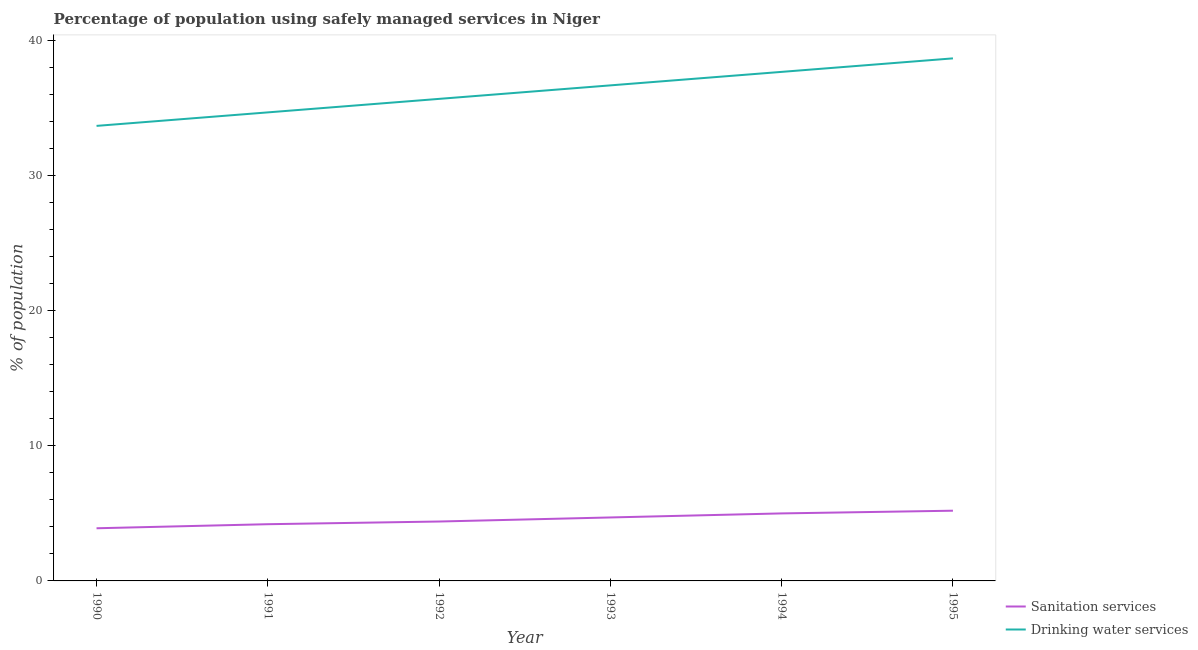How many different coloured lines are there?
Offer a terse response. 2. Across all years, what is the maximum percentage of population who used sanitation services?
Offer a very short reply. 5.2. Across all years, what is the minimum percentage of population who used drinking water services?
Your answer should be compact. 33.7. In which year was the percentage of population who used drinking water services maximum?
Provide a short and direct response. 1995. In which year was the percentage of population who used sanitation services minimum?
Keep it short and to the point. 1990. What is the total percentage of population who used drinking water services in the graph?
Your response must be concise. 217.2. What is the difference between the percentage of population who used sanitation services in 1994 and the percentage of population who used drinking water services in 1992?
Your response must be concise. -30.7. What is the average percentage of population who used sanitation services per year?
Give a very brief answer. 4.57. In the year 1993, what is the difference between the percentage of population who used sanitation services and percentage of population who used drinking water services?
Offer a terse response. -32. What is the ratio of the percentage of population who used sanitation services in 1990 to that in 1994?
Ensure brevity in your answer.  0.78. Is the difference between the percentage of population who used drinking water services in 1992 and 1995 greater than the difference between the percentage of population who used sanitation services in 1992 and 1995?
Give a very brief answer. No. What is the difference between the highest and the second highest percentage of population who used drinking water services?
Offer a terse response. 1. What is the difference between the highest and the lowest percentage of population who used sanitation services?
Provide a short and direct response. 1.3. Is the sum of the percentage of population who used drinking water services in 1990 and 1992 greater than the maximum percentage of population who used sanitation services across all years?
Your answer should be very brief. Yes. Does the percentage of population who used sanitation services monotonically increase over the years?
Offer a very short reply. Yes. Is the percentage of population who used sanitation services strictly less than the percentage of population who used drinking water services over the years?
Your answer should be very brief. Yes. How many lines are there?
Keep it short and to the point. 2. Are the values on the major ticks of Y-axis written in scientific E-notation?
Keep it short and to the point. No. Where does the legend appear in the graph?
Keep it short and to the point. Bottom right. How many legend labels are there?
Provide a succinct answer. 2. How are the legend labels stacked?
Your answer should be very brief. Vertical. What is the title of the graph?
Your answer should be compact. Percentage of population using safely managed services in Niger. Does "Diesel" appear as one of the legend labels in the graph?
Offer a terse response. No. What is the label or title of the Y-axis?
Provide a succinct answer. % of population. What is the % of population in Drinking water services in 1990?
Your answer should be compact. 33.7. What is the % of population in Drinking water services in 1991?
Offer a terse response. 34.7. What is the % of population of Drinking water services in 1992?
Your response must be concise. 35.7. What is the % of population of Sanitation services in 1993?
Your response must be concise. 4.7. What is the % of population in Drinking water services in 1993?
Your answer should be compact. 36.7. What is the % of population of Drinking water services in 1994?
Offer a very short reply. 37.7. What is the % of population of Sanitation services in 1995?
Your response must be concise. 5.2. What is the % of population of Drinking water services in 1995?
Your answer should be compact. 38.7. Across all years, what is the maximum % of population of Drinking water services?
Make the answer very short. 38.7. Across all years, what is the minimum % of population of Drinking water services?
Offer a very short reply. 33.7. What is the total % of population of Sanitation services in the graph?
Offer a terse response. 27.4. What is the total % of population of Drinking water services in the graph?
Your answer should be very brief. 217.2. What is the difference between the % of population in Sanitation services in 1990 and that in 1991?
Ensure brevity in your answer.  -0.3. What is the difference between the % of population of Drinking water services in 1990 and that in 1991?
Your answer should be very brief. -1. What is the difference between the % of population of Sanitation services in 1990 and that in 1992?
Ensure brevity in your answer.  -0.5. What is the difference between the % of population in Drinking water services in 1990 and that in 1993?
Your response must be concise. -3. What is the difference between the % of population of Sanitation services in 1990 and that in 1995?
Keep it short and to the point. -1.3. What is the difference between the % of population in Drinking water services in 1990 and that in 1995?
Offer a very short reply. -5. What is the difference between the % of population in Sanitation services in 1991 and that in 1992?
Provide a short and direct response. -0.2. What is the difference between the % of population in Sanitation services in 1991 and that in 1993?
Make the answer very short. -0.5. What is the difference between the % of population in Drinking water services in 1991 and that in 1993?
Your answer should be very brief. -2. What is the difference between the % of population of Drinking water services in 1991 and that in 1994?
Your response must be concise. -3. What is the difference between the % of population of Sanitation services in 1992 and that in 1993?
Your answer should be compact. -0.3. What is the difference between the % of population of Drinking water services in 1992 and that in 1993?
Your answer should be compact. -1. What is the difference between the % of population of Drinking water services in 1992 and that in 1994?
Make the answer very short. -2. What is the difference between the % of population in Sanitation services in 1992 and that in 1995?
Your response must be concise. -0.8. What is the difference between the % of population of Sanitation services in 1993 and that in 1994?
Give a very brief answer. -0.3. What is the difference between the % of population in Drinking water services in 1993 and that in 1994?
Your answer should be compact. -1. What is the difference between the % of population in Sanitation services in 1993 and that in 1995?
Offer a very short reply. -0.5. What is the difference between the % of population in Drinking water services in 1993 and that in 1995?
Your answer should be very brief. -2. What is the difference between the % of population in Sanitation services in 1994 and that in 1995?
Provide a short and direct response. -0.2. What is the difference between the % of population in Drinking water services in 1994 and that in 1995?
Give a very brief answer. -1. What is the difference between the % of population of Sanitation services in 1990 and the % of population of Drinking water services in 1991?
Offer a very short reply. -30.8. What is the difference between the % of population of Sanitation services in 1990 and the % of population of Drinking water services in 1992?
Give a very brief answer. -31.8. What is the difference between the % of population in Sanitation services in 1990 and the % of population in Drinking water services in 1993?
Ensure brevity in your answer.  -32.8. What is the difference between the % of population in Sanitation services in 1990 and the % of population in Drinking water services in 1994?
Give a very brief answer. -33.8. What is the difference between the % of population of Sanitation services in 1990 and the % of population of Drinking water services in 1995?
Provide a succinct answer. -34.8. What is the difference between the % of population in Sanitation services in 1991 and the % of population in Drinking water services in 1992?
Provide a succinct answer. -31.5. What is the difference between the % of population of Sanitation services in 1991 and the % of population of Drinking water services in 1993?
Keep it short and to the point. -32.5. What is the difference between the % of population in Sanitation services in 1991 and the % of population in Drinking water services in 1994?
Provide a short and direct response. -33.5. What is the difference between the % of population in Sanitation services in 1991 and the % of population in Drinking water services in 1995?
Provide a short and direct response. -34.5. What is the difference between the % of population of Sanitation services in 1992 and the % of population of Drinking water services in 1993?
Provide a succinct answer. -32.3. What is the difference between the % of population of Sanitation services in 1992 and the % of population of Drinking water services in 1994?
Offer a very short reply. -33.3. What is the difference between the % of population of Sanitation services in 1992 and the % of population of Drinking water services in 1995?
Your answer should be compact. -34.3. What is the difference between the % of population of Sanitation services in 1993 and the % of population of Drinking water services in 1994?
Provide a short and direct response. -33. What is the difference between the % of population of Sanitation services in 1993 and the % of population of Drinking water services in 1995?
Your response must be concise. -34. What is the difference between the % of population in Sanitation services in 1994 and the % of population in Drinking water services in 1995?
Your answer should be compact. -33.7. What is the average % of population of Sanitation services per year?
Provide a short and direct response. 4.57. What is the average % of population of Drinking water services per year?
Ensure brevity in your answer.  36.2. In the year 1990, what is the difference between the % of population of Sanitation services and % of population of Drinking water services?
Offer a terse response. -29.8. In the year 1991, what is the difference between the % of population in Sanitation services and % of population in Drinking water services?
Provide a short and direct response. -30.5. In the year 1992, what is the difference between the % of population in Sanitation services and % of population in Drinking water services?
Keep it short and to the point. -31.3. In the year 1993, what is the difference between the % of population in Sanitation services and % of population in Drinking water services?
Make the answer very short. -32. In the year 1994, what is the difference between the % of population in Sanitation services and % of population in Drinking water services?
Your answer should be very brief. -32.7. In the year 1995, what is the difference between the % of population of Sanitation services and % of population of Drinking water services?
Give a very brief answer. -33.5. What is the ratio of the % of population in Sanitation services in 1990 to that in 1991?
Offer a terse response. 0.93. What is the ratio of the % of population of Drinking water services in 1990 to that in 1991?
Ensure brevity in your answer.  0.97. What is the ratio of the % of population of Sanitation services in 1990 to that in 1992?
Offer a very short reply. 0.89. What is the ratio of the % of population in Drinking water services in 1990 to that in 1992?
Provide a short and direct response. 0.94. What is the ratio of the % of population of Sanitation services in 1990 to that in 1993?
Provide a succinct answer. 0.83. What is the ratio of the % of population in Drinking water services in 1990 to that in 1993?
Make the answer very short. 0.92. What is the ratio of the % of population in Sanitation services in 1990 to that in 1994?
Provide a short and direct response. 0.78. What is the ratio of the % of population in Drinking water services in 1990 to that in 1994?
Keep it short and to the point. 0.89. What is the ratio of the % of population of Sanitation services in 1990 to that in 1995?
Your answer should be very brief. 0.75. What is the ratio of the % of population in Drinking water services in 1990 to that in 1995?
Offer a very short reply. 0.87. What is the ratio of the % of population in Sanitation services in 1991 to that in 1992?
Make the answer very short. 0.95. What is the ratio of the % of population in Sanitation services in 1991 to that in 1993?
Provide a succinct answer. 0.89. What is the ratio of the % of population in Drinking water services in 1991 to that in 1993?
Offer a terse response. 0.95. What is the ratio of the % of population of Sanitation services in 1991 to that in 1994?
Your answer should be very brief. 0.84. What is the ratio of the % of population in Drinking water services in 1991 to that in 1994?
Ensure brevity in your answer.  0.92. What is the ratio of the % of population in Sanitation services in 1991 to that in 1995?
Provide a short and direct response. 0.81. What is the ratio of the % of population in Drinking water services in 1991 to that in 1995?
Your response must be concise. 0.9. What is the ratio of the % of population in Sanitation services in 1992 to that in 1993?
Make the answer very short. 0.94. What is the ratio of the % of population of Drinking water services in 1992 to that in 1993?
Provide a succinct answer. 0.97. What is the ratio of the % of population in Sanitation services in 1992 to that in 1994?
Provide a succinct answer. 0.88. What is the ratio of the % of population of Drinking water services in 1992 to that in 1994?
Offer a very short reply. 0.95. What is the ratio of the % of population of Sanitation services in 1992 to that in 1995?
Your answer should be compact. 0.85. What is the ratio of the % of population in Drinking water services in 1992 to that in 1995?
Ensure brevity in your answer.  0.92. What is the ratio of the % of population in Sanitation services in 1993 to that in 1994?
Make the answer very short. 0.94. What is the ratio of the % of population in Drinking water services in 1993 to that in 1994?
Offer a very short reply. 0.97. What is the ratio of the % of population of Sanitation services in 1993 to that in 1995?
Offer a very short reply. 0.9. What is the ratio of the % of population in Drinking water services in 1993 to that in 1995?
Make the answer very short. 0.95. What is the ratio of the % of population of Sanitation services in 1994 to that in 1995?
Provide a succinct answer. 0.96. What is the ratio of the % of population in Drinking water services in 1994 to that in 1995?
Your response must be concise. 0.97. 